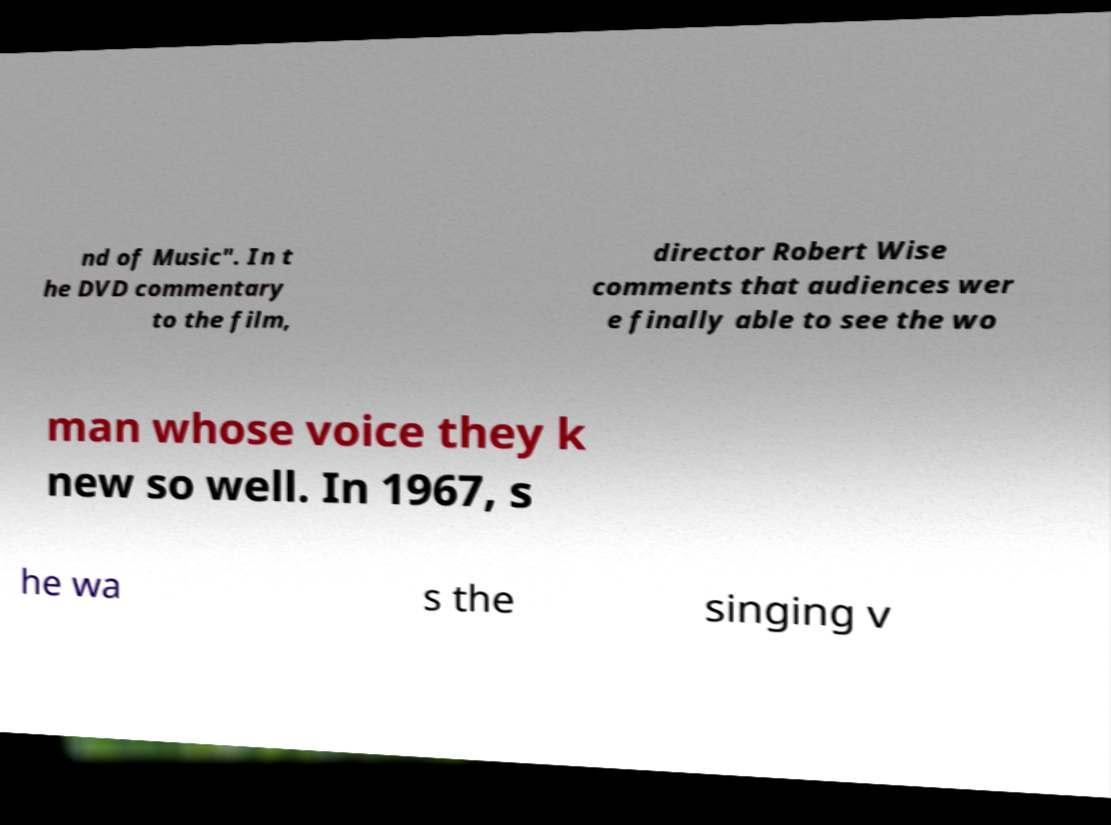Please identify and transcribe the text found in this image. nd of Music". In t he DVD commentary to the film, director Robert Wise comments that audiences wer e finally able to see the wo man whose voice they k new so well. In 1967, s he wa s the singing v 